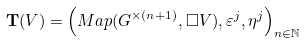<formula> <loc_0><loc_0><loc_500><loc_500>\mathbf T ( V ) = \left ( M a p ( G ^ { \times ( n + 1 ) } , \square V ) , \varepsilon ^ { j } , \eta ^ { j } \right ) _ { n \in \mathbb { N } }</formula> 